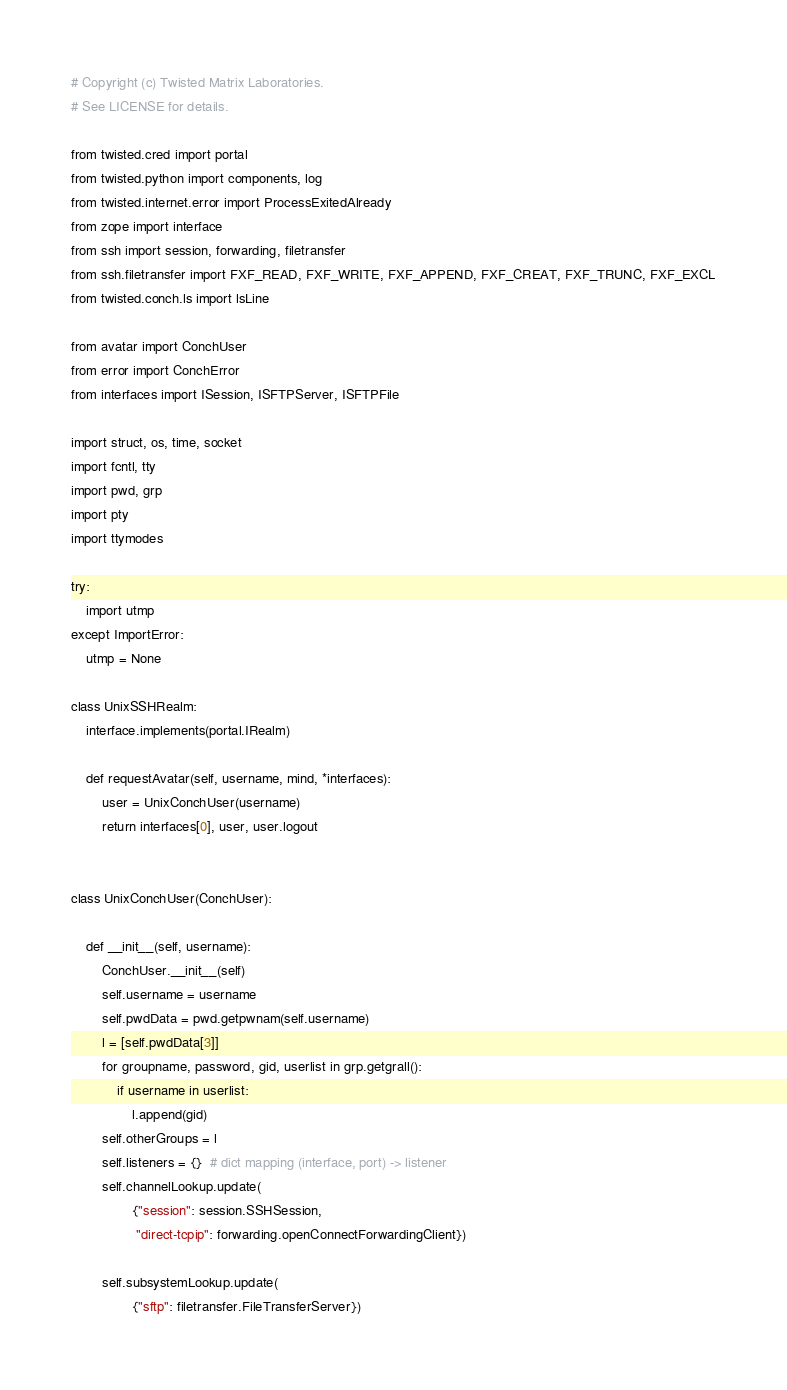Convert code to text. <code><loc_0><loc_0><loc_500><loc_500><_Python_># Copyright (c) Twisted Matrix Laboratories.
# See LICENSE for details.

from twisted.cred import portal
from twisted.python import components, log
from twisted.internet.error import ProcessExitedAlready
from zope import interface
from ssh import session, forwarding, filetransfer
from ssh.filetransfer import FXF_READ, FXF_WRITE, FXF_APPEND, FXF_CREAT, FXF_TRUNC, FXF_EXCL
from twisted.conch.ls import lsLine

from avatar import ConchUser
from error import ConchError
from interfaces import ISession, ISFTPServer, ISFTPFile

import struct, os, time, socket
import fcntl, tty
import pwd, grp
import pty
import ttymodes

try:
    import utmp
except ImportError:
    utmp = None

class UnixSSHRealm:
    interface.implements(portal.IRealm)

    def requestAvatar(self, username, mind, *interfaces):
        user = UnixConchUser(username)
        return interfaces[0], user, user.logout


class UnixConchUser(ConchUser):

    def __init__(self, username):
        ConchUser.__init__(self)
        self.username = username
        self.pwdData = pwd.getpwnam(self.username)
        l = [self.pwdData[3]]
        for groupname, password, gid, userlist in grp.getgrall():
            if username in userlist:
                l.append(gid)
        self.otherGroups = l
        self.listeners = {}  # dict mapping (interface, port) -> listener
        self.channelLookup.update(
                {"session": session.SSHSession,
                 "direct-tcpip": forwarding.openConnectForwardingClient})

        self.subsystemLookup.update(
                {"sftp": filetransfer.FileTransferServer})
</code> 